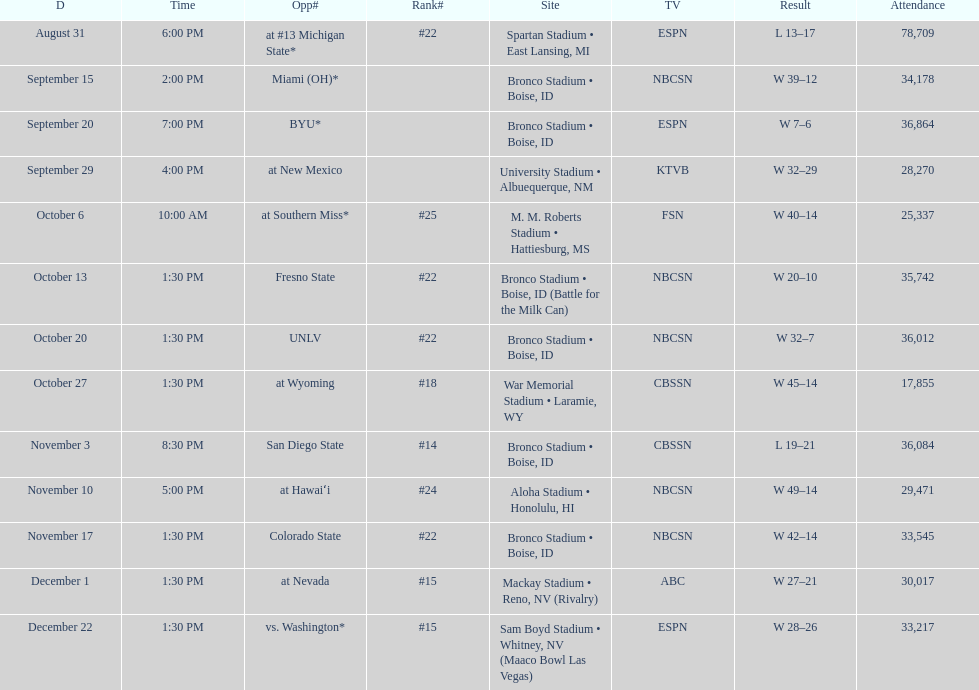What was the most consecutive wins for the team shown in the season? 7. 